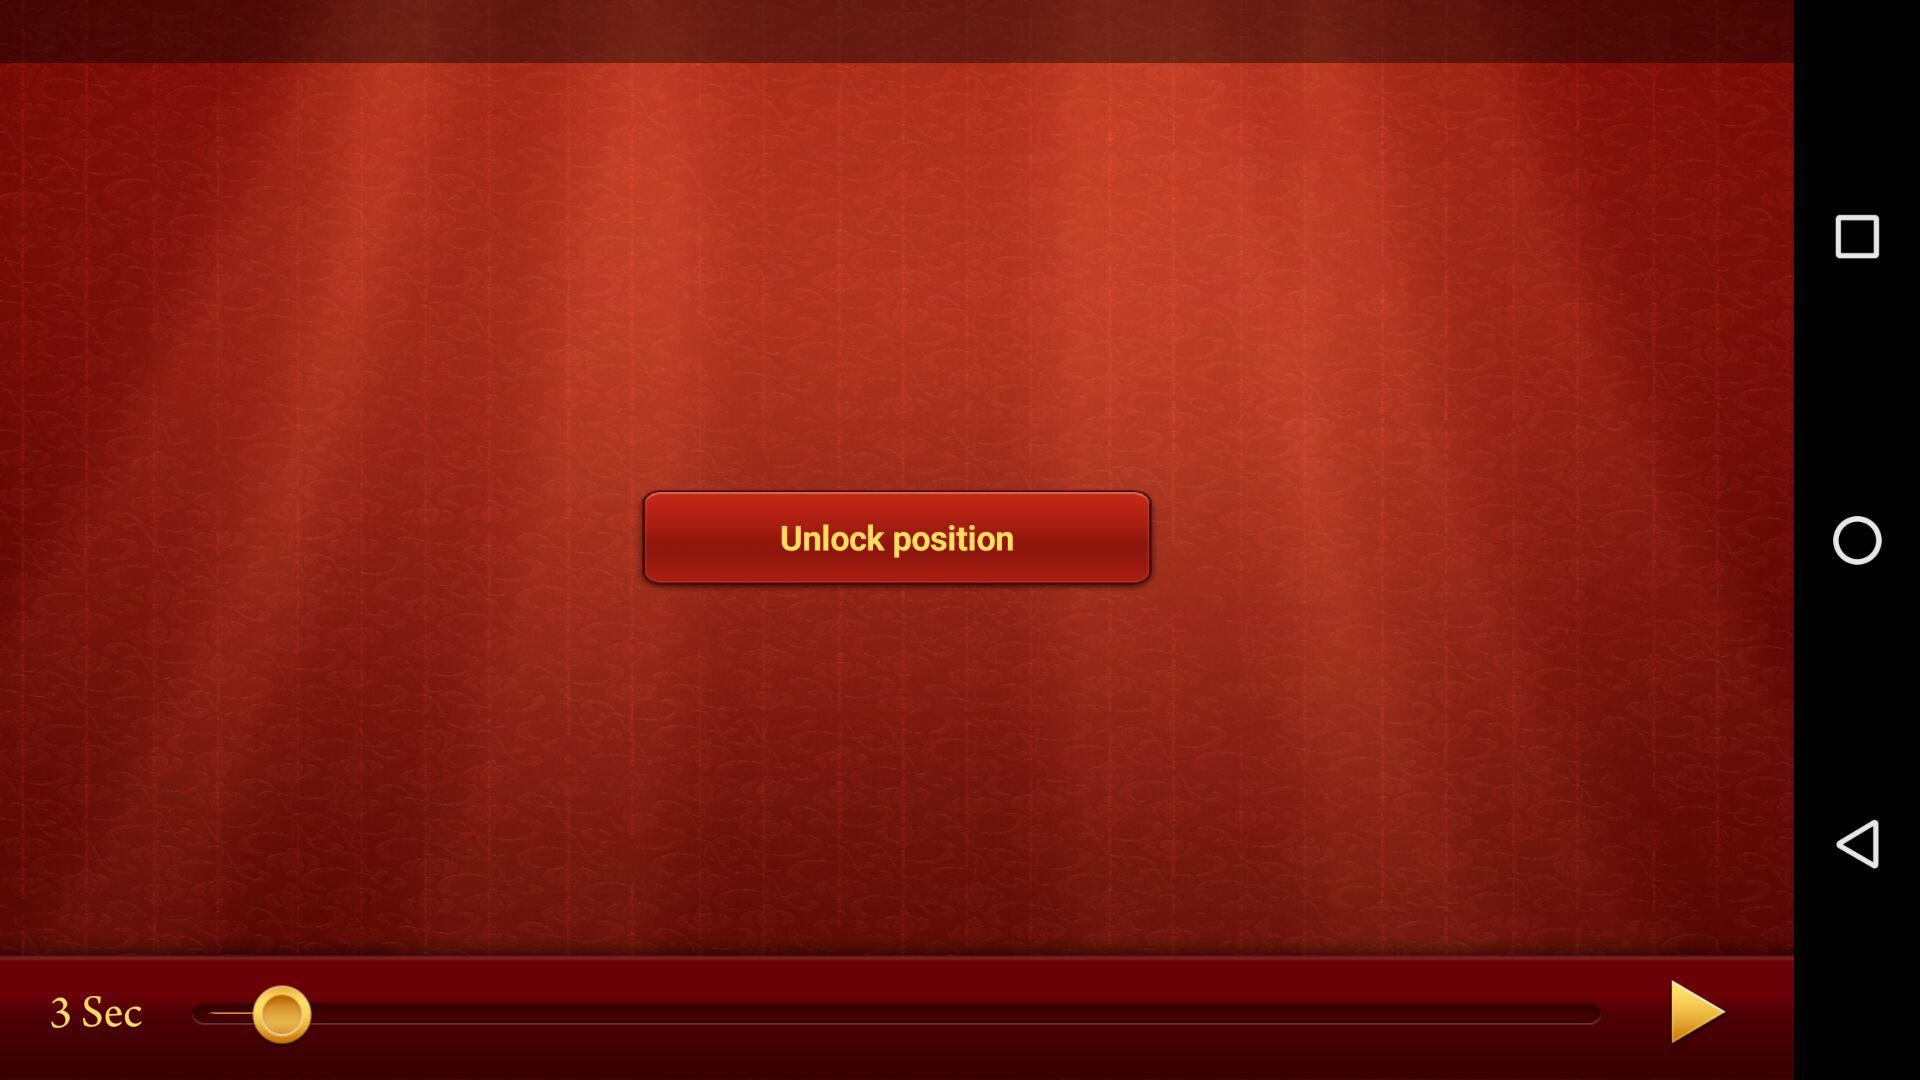What is the status of "Background Music"? The status is "on". 